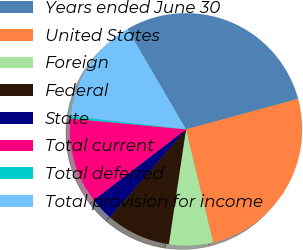<chart> <loc_0><loc_0><loc_500><loc_500><pie_chart><fcel>Years ended June 30<fcel>United States<fcel>Foreign<fcel>Federal<fcel>State<fcel>Total current<fcel>Total deferred<fcel>Total provision for income<nl><fcel>29.17%<fcel>25.47%<fcel>6.12%<fcel>9.0%<fcel>3.24%<fcel>11.88%<fcel>0.36%<fcel>14.76%<nl></chart> 